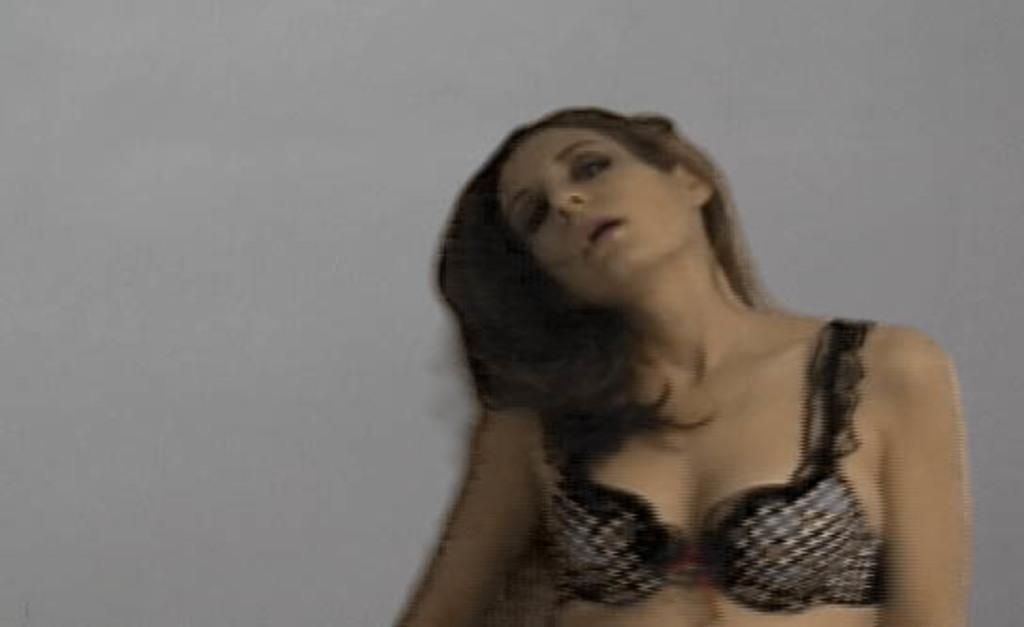What is the main subject of the image? There is a woman in the image. Where is the woman located in the image? The woman is standing near a wall. Can you describe the quality of the image? The image is slightly blurred. What type of honey is the woman collecting from the swing in the image? There is no honey, swing, or any activity involving honey collection in the image. 